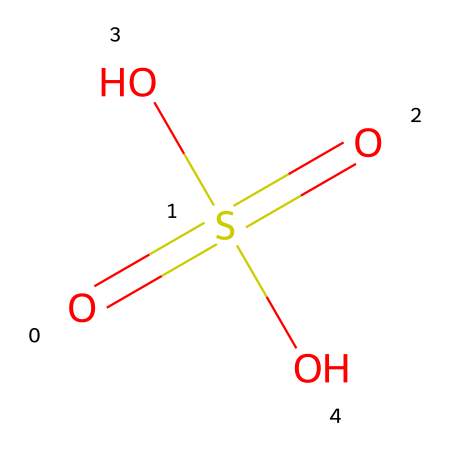What is the name of this chemical? The SMILES representation indicates the presence of sulfur and oxygen atoms arranged with specific bonding patterns. Analyzing the structure, this is recognized as sulfuric acid, a well-known compound in lead-acid batteries.
Answer: sulfuric acid How many oxygen atoms are present? By examining the SMILES notation, O=S(=O)(O)O, it is clear that there are four oxygen atoms (two doubly bonded and two singly bonded) associated with the sulfur atom.
Answer: four What is the oxidation state of sulfur in this compound? In sulfuric acid, sulfur is bonded to four oxygens: two with double bonds and two with single bonds. The formal charge calculation reveals that the oxidation state of sulfur in this compound is +6.
Answer: +6 What type of acids does this compound belong to? Sulfuric acid fits the category of strong acids due to its complete ionization in water and its ability to donate protons readily. This characteristic makes it a strong mineral acid.
Answer: strong mineral acid How does the molecular structure relate to its use in batteries? The presence of multiple oxygen atoms and the strong acidic nature allows sulfuric acid to participate in redox reactions. The ability to donate protons helps facilitate the electrochemical processes that occur in lead-acid batteries, storing and delivering energy effectively.
Answer: electrochemical processes What is the significance of the sulfate ion formed in the battery reactions? The sulfate ion (derived from sulfuric acid) plays a crucial role in the lead-acid battery reactions. It participates in the formation of lead sulfate during discharge and is reformed to sulfuric acid during charging, making it essential for the battery's operation and efficiency.
Answer: essential for operation 